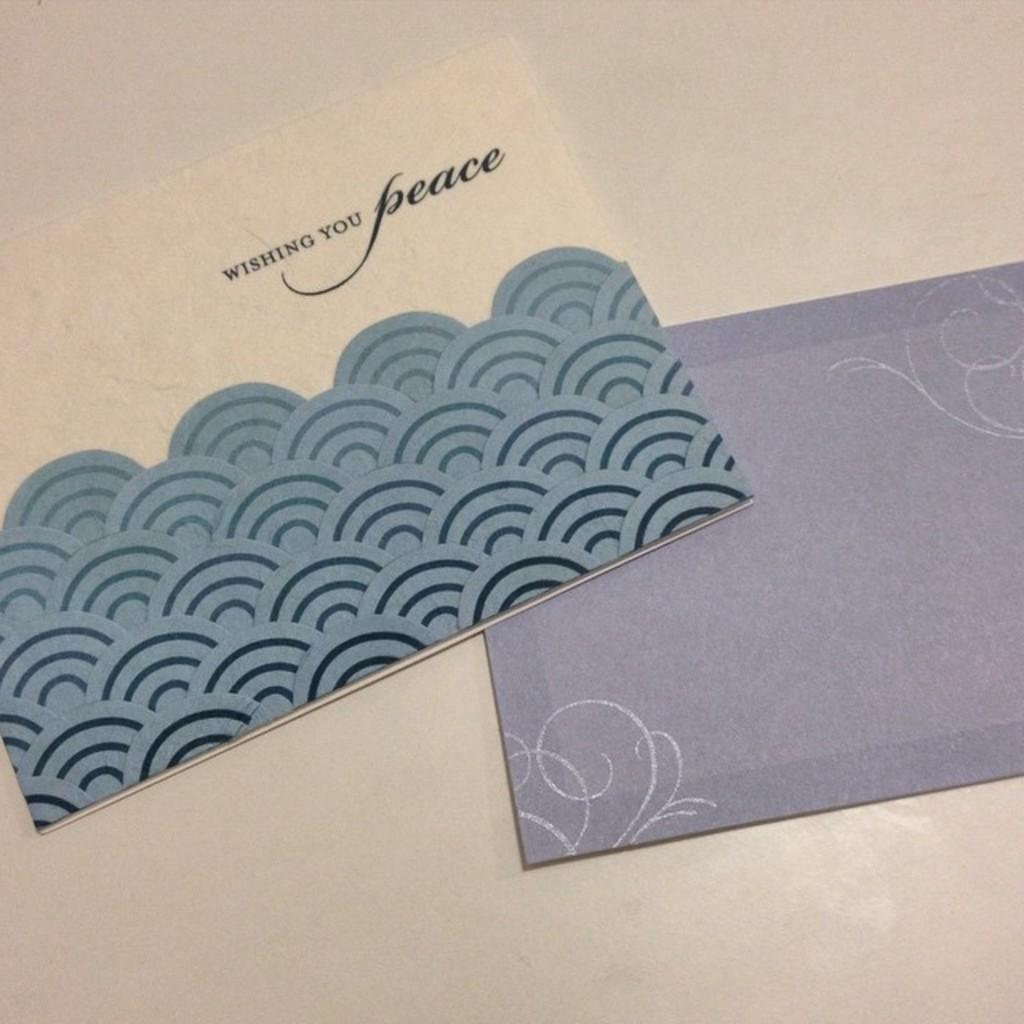What objects are present in the image? There are envelopes in the image. Where are the envelopes located? The envelopes are placed on a platform. What is the size of the sneeze in the image? There is no sneeze present in the image. How is the string used in the image? There is no string present in the image. 